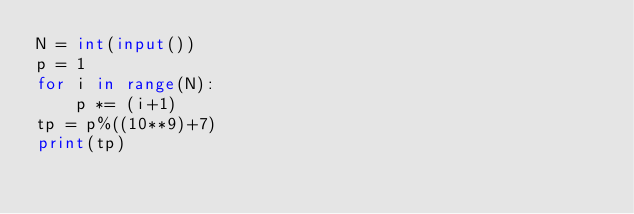<code> <loc_0><loc_0><loc_500><loc_500><_Python_>N = int(input())
p = 1
for i in range(N):
    p *= (i+1)
tp = p%((10**9)+7)
print(tp)</code> 